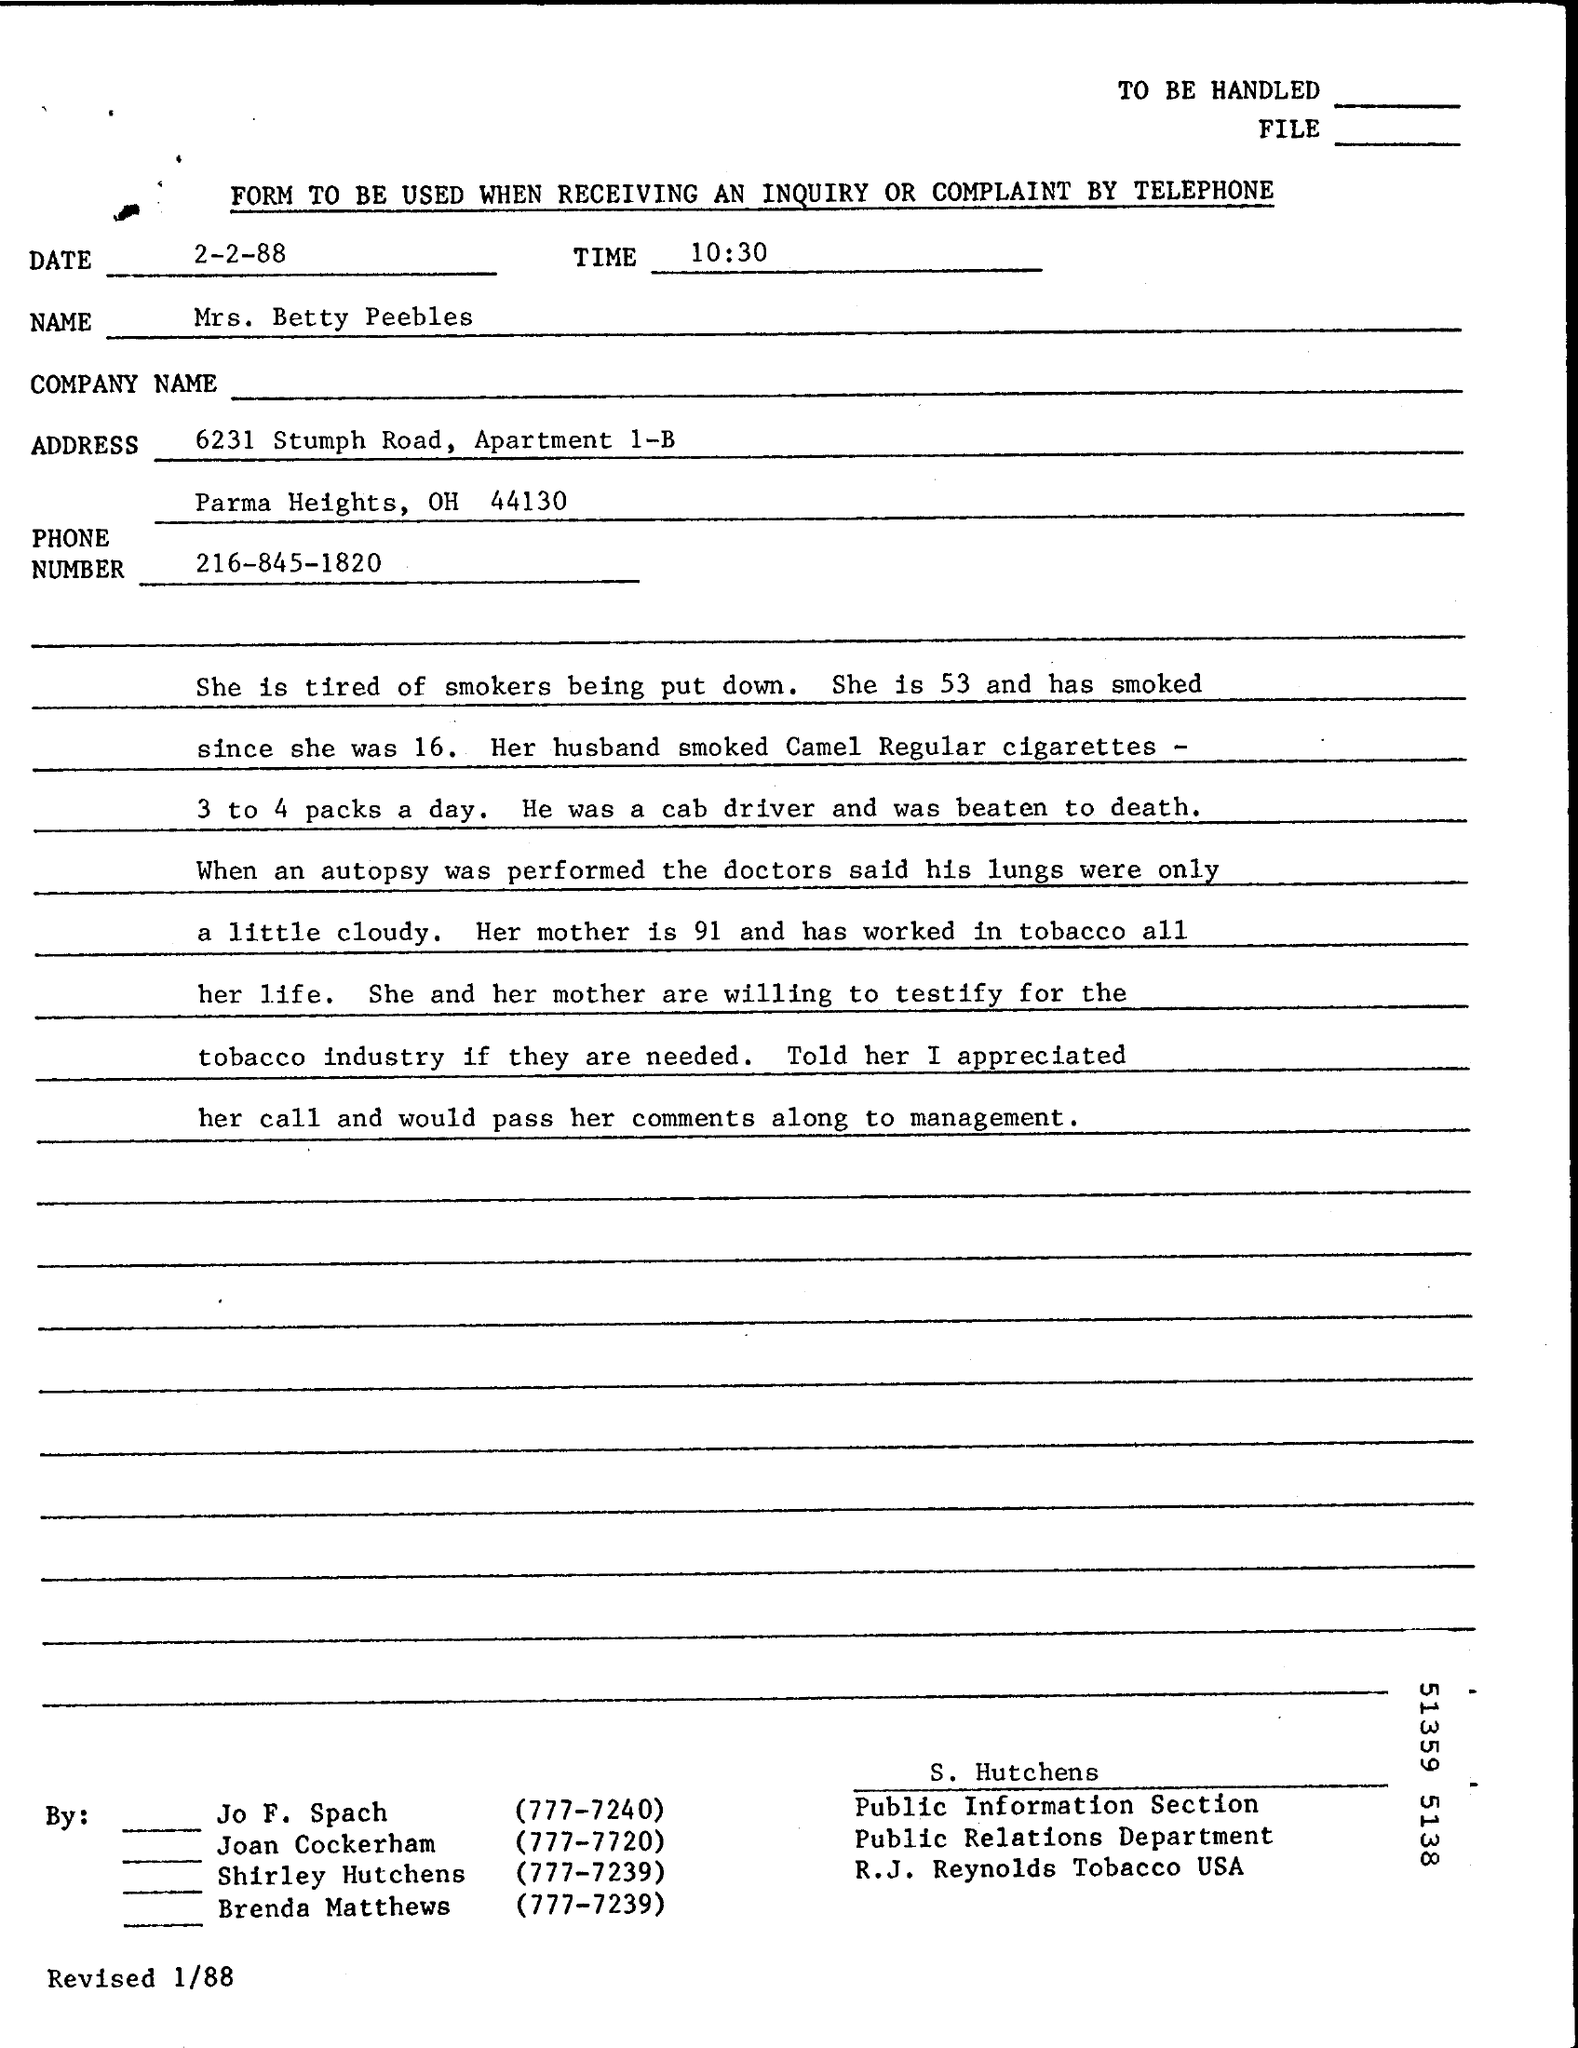Point out several critical features in this image. The phone number is 216-845-1820. On February 2nd, 1988, the date was... It is currently 10:30. 